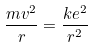<formula> <loc_0><loc_0><loc_500><loc_500>\frac { m v ^ { 2 } } { r } = \frac { k e ^ { 2 } } { r ^ { 2 } }</formula> 